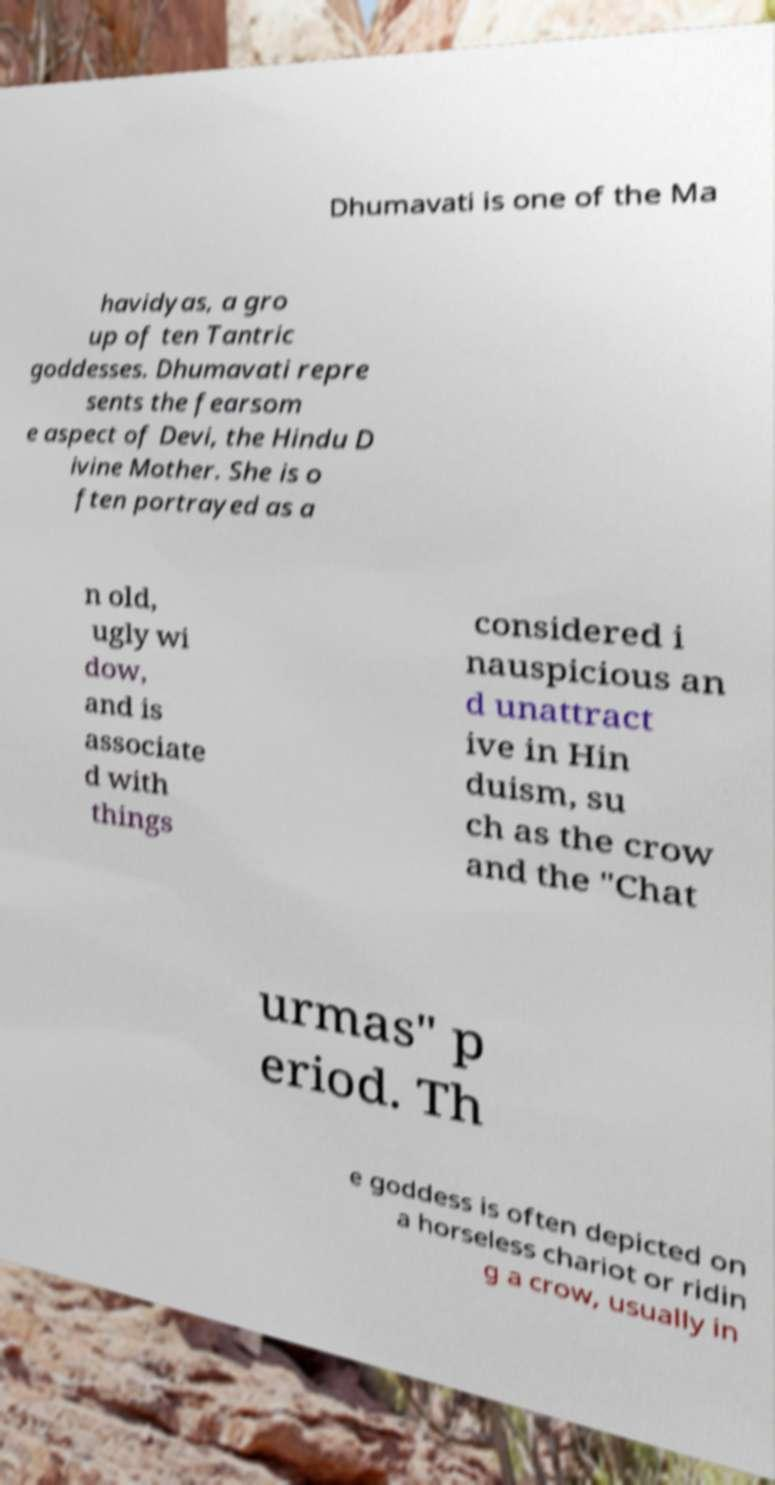Can you read and provide the text displayed in the image?This photo seems to have some interesting text. Can you extract and type it out for me? Dhumavati is one of the Ma havidyas, a gro up of ten Tantric goddesses. Dhumavati repre sents the fearsom e aspect of Devi, the Hindu D ivine Mother. She is o ften portrayed as a n old, ugly wi dow, and is associate d with things considered i nauspicious an d unattract ive in Hin duism, su ch as the crow and the "Chat urmas" p eriod. Th e goddess is often depicted on a horseless chariot or ridin g a crow, usually in 